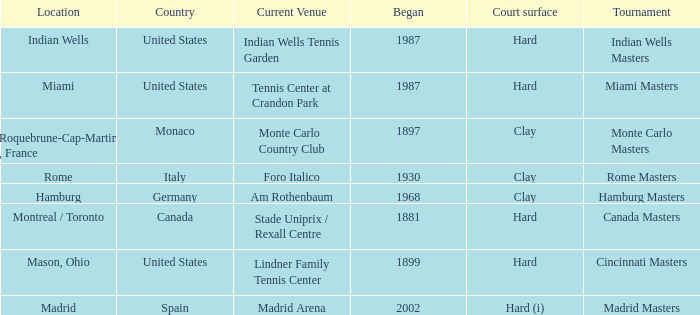Which tournaments current venue is the Madrid Arena? Madrid Masters. 